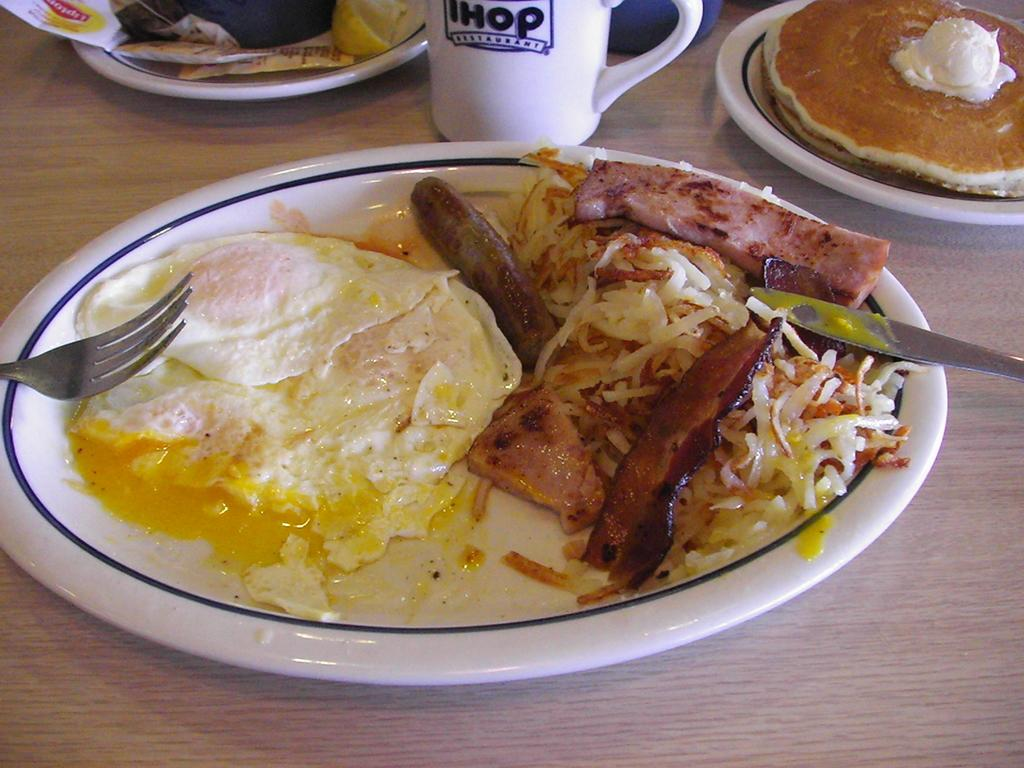What is present on the table in the image? There is a cup and food in a plate on the table in the image. What type of food is on the plate? The provided facts do not specify the type of food on the plate. Where are the cup and plate located in relation to each other? The cup and plate are placed on the table in the image. How many cacti are present on the table in the image? There are no cacti present on the table in the image. What type of iron object can be seen near the cup in the image? There is no iron object present near the cup in the image. 